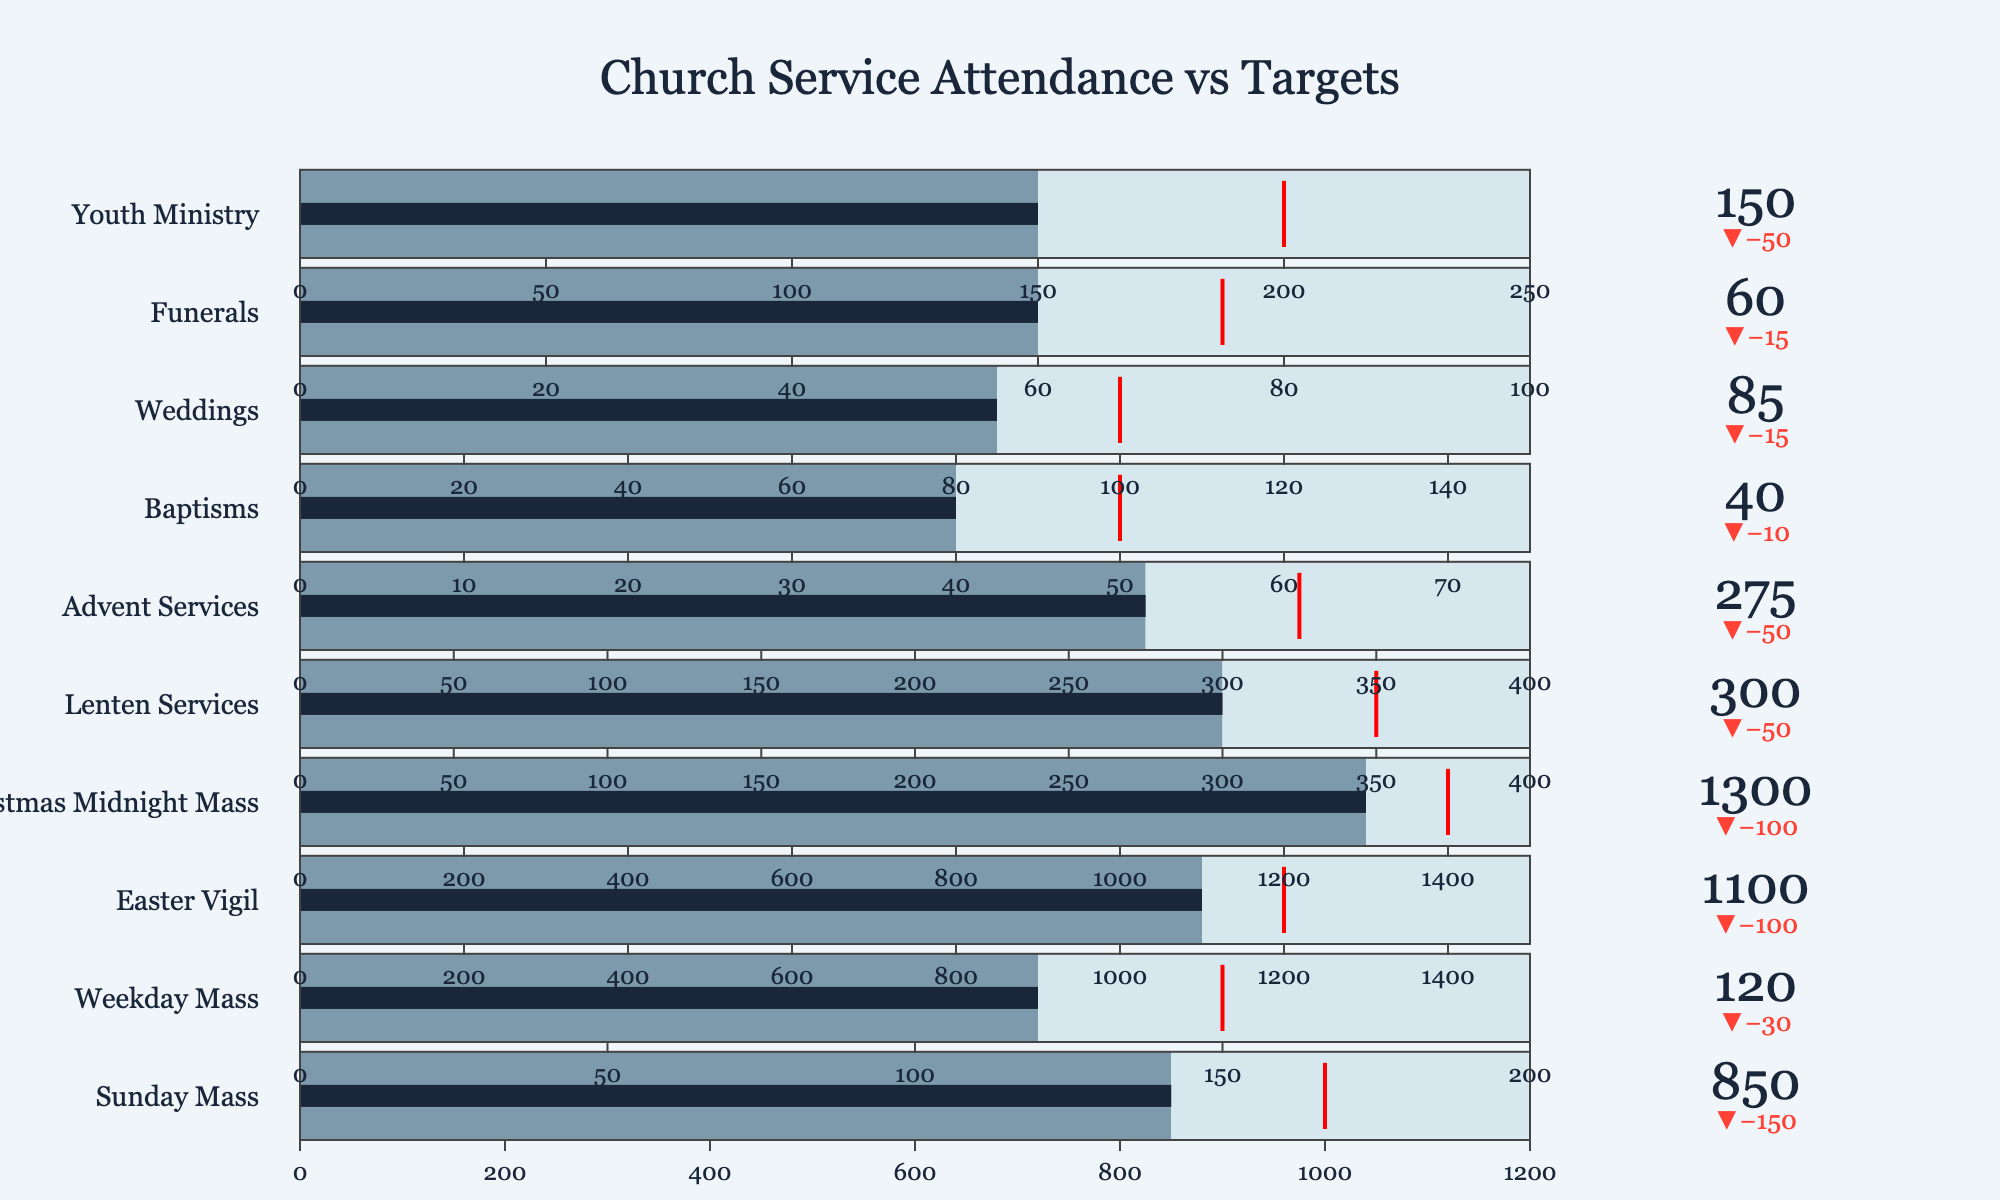What's the title of the chart? The title is the text at the top of the chart that describes what the chart is about. Here, it reads "Church Service Attendance vs Targets".
Answer: Church Service Attendance vs Targets Which service has the highest actual attendance? The actual attendance values are displayed as numbers on each bullet chart. The service with the highest number is "Christmas Midnight Mass" with 1300.
Answer: Christmas Midnight Mass How many services have actual attendance that meets or exceeds their target attendance? Check each bullet chart to see if the actual attendance value is equal to or greater than the target attendance value indicated by the red threshold line. The services that meet or exceed the target are "Easter Vigil" and "Christmas Midnight Mass". Thus, there are 2 such services.
Answer: 2 By how much does the "Sunday Mass" attendance fall short of its target? Subtract the actual attendance of "Sunday Mass" (850) from its target attendance (1000). The difference is 1000 - 850 = 150.
Answer: 150 Which service has the largest difference between actual attendance and target attendance, and what is this difference? Calculate the difference between actual attendance and target attendance for each service and identify the largest one. "Christmas Midnight Mass" has an actual attendance of 1300 and a target of 1400, so the difference is 1400 - 1300 = 100. This is the largest difference.
Answer: Christmas Midnight Mass, 100 How much above the target attendance is "Easter Vigil"? Subtract the target attendance of "Easter Vigil" (1200) from its actual attendance (1100): 1100 - 1200 = -100. The actual is below, not above.
Answer: None What service has the lowest actual attendance, and what is the value? The lowest number in the actual attendance values indicated on the bullet charts. "Baptisms" have the lowest actual attendance of 40.
Answer: Baptisms, 40 What is the combined actual attendance for weekday and Sunday masses? Add the actual attendance for the "Sunday Mass" (850) and "Weekday Mass" (120): 850 + 120 = 970.
Answer: 970 In which service is the difference between actual attendance and maximum capacity the greatest? Find the service with the largest difference by subtracting actual attendance from maximum capacity for each service. "Christmas Midnight Mass" has the maximum capacity of 1500 and actual attendance of 1300. The difference is 1500 - 1300 = 200. This is the greatest difference.
Answer: Christmas Midnight Mass Which service type has the actual attendance most similar to its maximum capacity? Compare the actual attendance with maximum capacity for all services to find the one with the smallest difference. "Baptisms" has the capacity of 75 and actual attendance of 40, the difference is 35, which is smaller compared to others.
Answer: Baptisms 